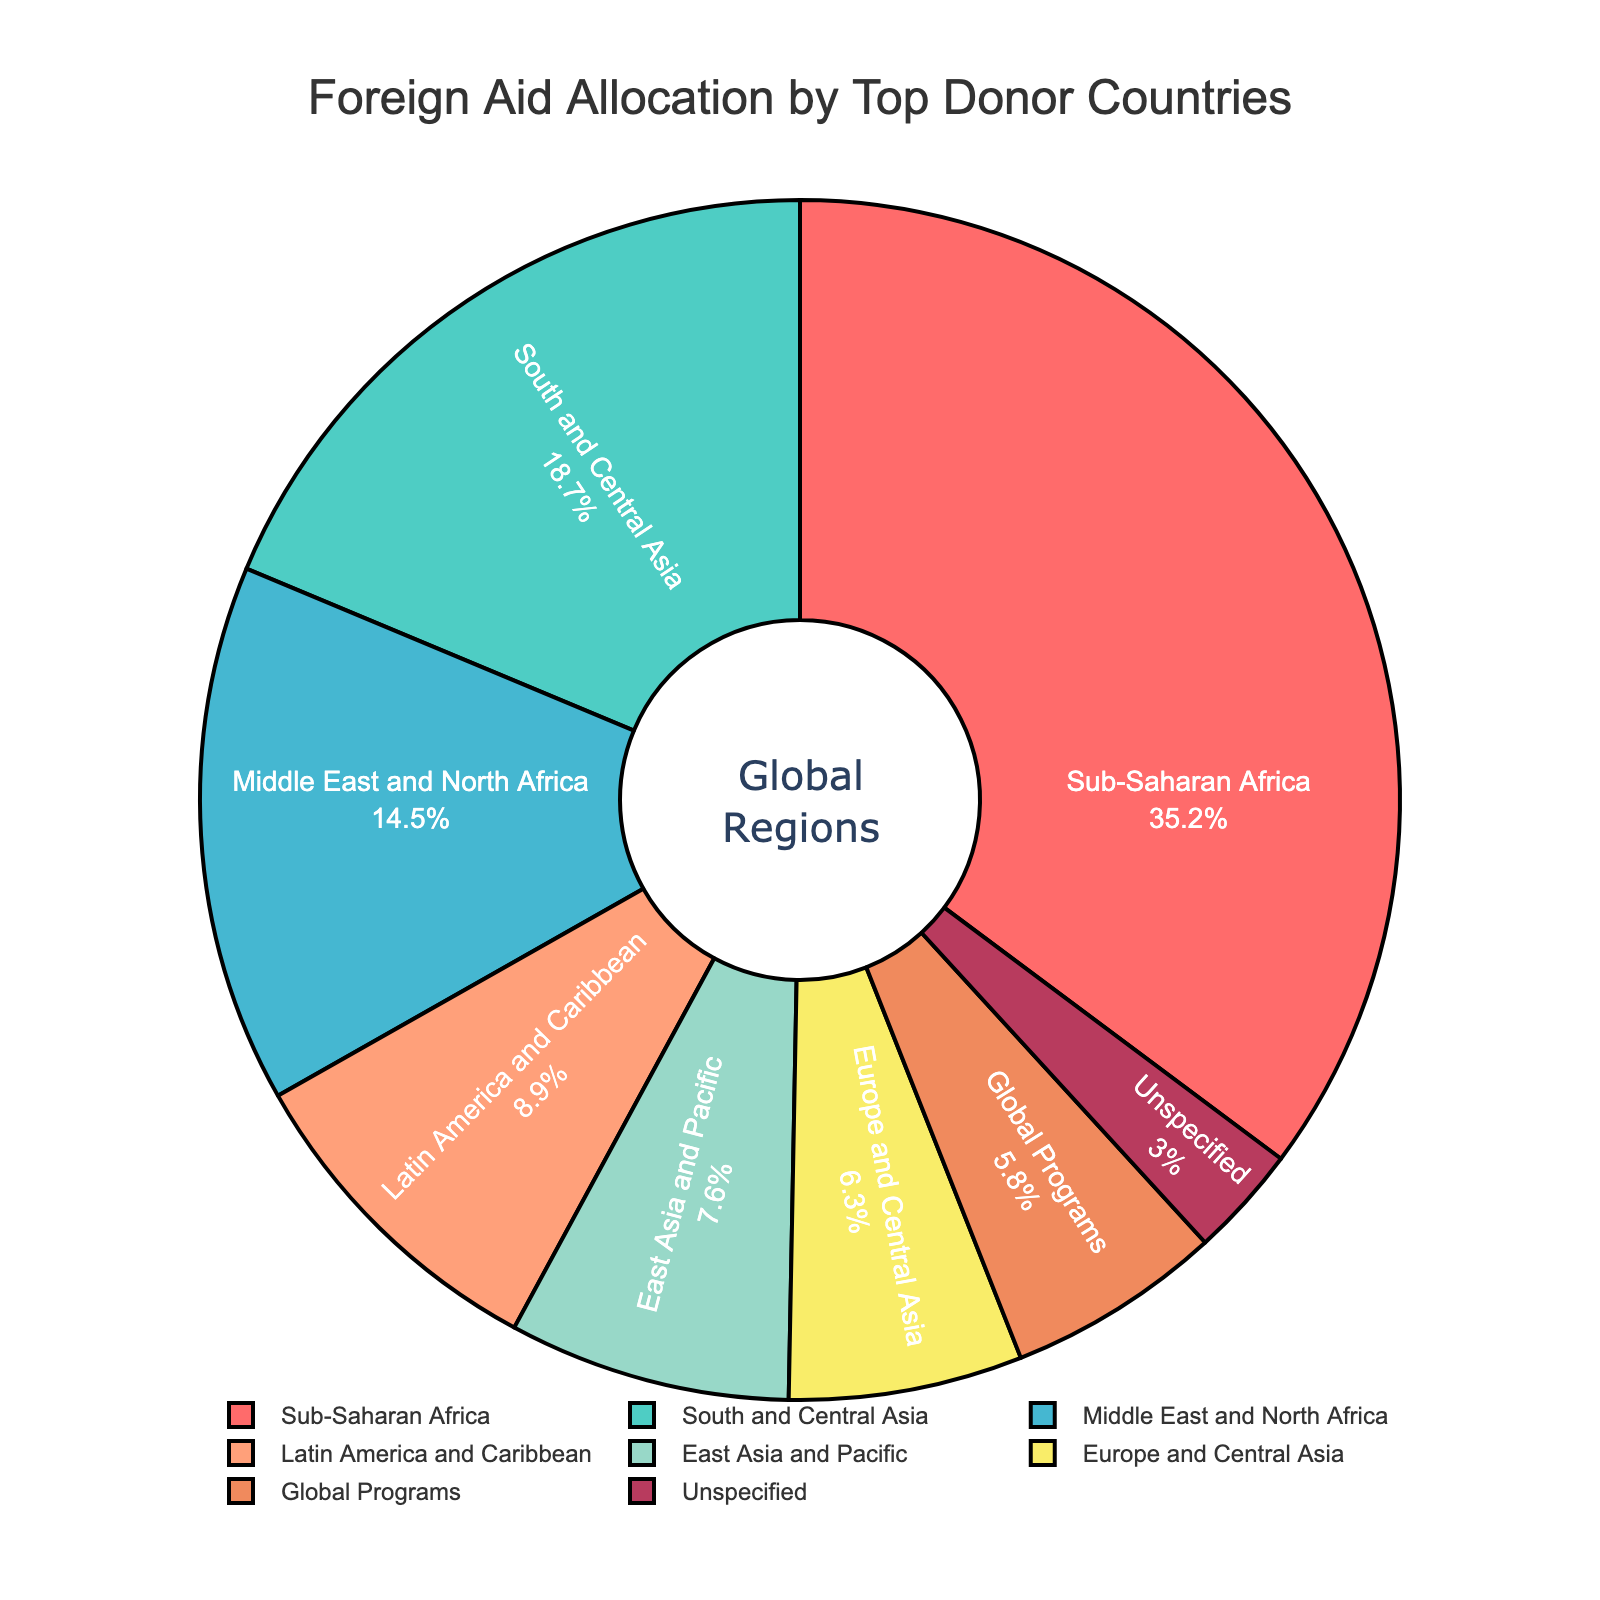what is the total percentage of aid allocated to regions other than Sub-Saharan Africa? Subtract the percentage of Sub-Saharan Africa from 100%: 100% - 35.2% = 64.8%
Answer: 64.8% Which region receives more aid, East Asia and Pacific or Latin America and Caribbean? Compare the percentages of East Asia and Pacific (7.6%) and Latin America and Caribbean (8.9%): 8.9% is greater than 7.6%
Answer: Latin America and Caribbean Is the aid allocation to South and Central Asia greater than the combined allocation to Europe and Central Asia and Global Programs? Add the percentages of Europe and Central Asia (6.3%) and Global Programs (5.8%), then compare the sum to that of South and Central Asia (18.7%): 6.3% + 5.8% = 12.1%, which is less than 18.7%
Answer: Yes What is the sum of the aid percentages allocated to Latin America and Caribbean and Middle East and North Africa? Add the percentages of Latin America and Caribbean (8.9%) and Middle East and North Africa (14.5%): 8.9% + 14.5% = 23.4%
Answer: 23.4% Which region has the smallest aid allocation and how much is it? Look at the percentages of all regions and identify the smallest one, which is 'Unspecified' with 3.0%
Answer: Unspecified, 3.0% How much more aid is allocated to Sub-Saharan Africa compared to Europe and Central Asia? Subtract the percentage of Europe and Central Asia (6.3%) from Sub-Saharan Africa (35.2%): 35.2% - 6.3% = 28.9%
Answer: 28.9% What is the average aid allocation percentage for the Middle East and North Africa, Latin America and Caribbean, and East Asia and Pacific regions? Add the percentages for the three regions (14.5% + 8.9% + 7.6%), then divide by the number of regions (3): (14.5% + 8.9% + 7.6%) / 3 = 31% / 3 = 10.33%
Answer: 10.33% Which regions have aid allocations greater than 10%? Identify each region's percentage and see which ones are greater than 10%: Sub-Saharan Africa (35.2%), South and Central Asia (18.7%), and Middle East and North Africa (14.5%)
Answer: Sub-Saharan Africa, South and Central Asia, Middle East and North Africa 